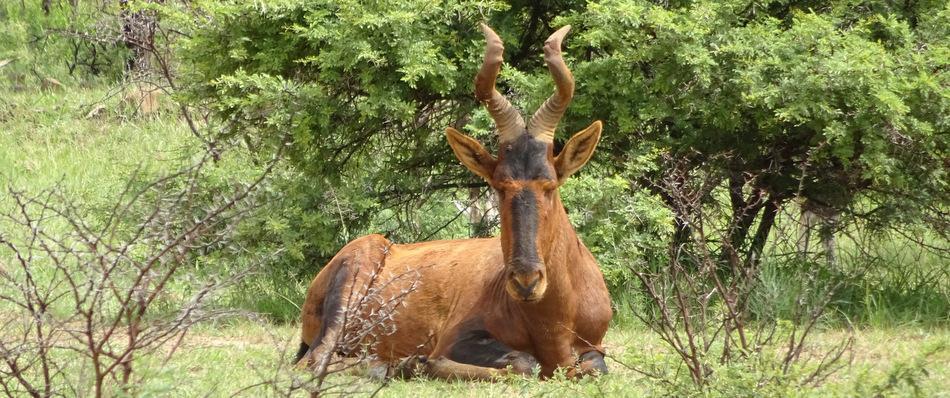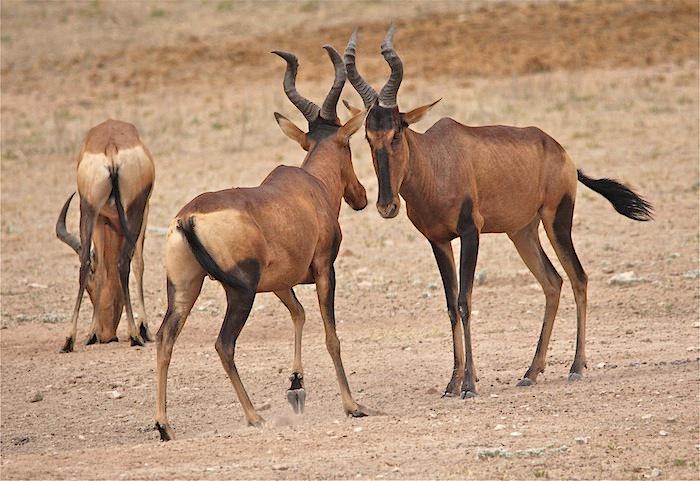The first image is the image on the left, the second image is the image on the right. Evaluate the accuracy of this statement regarding the images: "There are less than 5 animals.". Is it true? Answer yes or no. Yes. The first image is the image on the left, the second image is the image on the right. Assess this claim about the two images: "There is one horned mammal sitting in the left image, and multiple standing in the right.". Correct or not? Answer yes or no. Yes. 